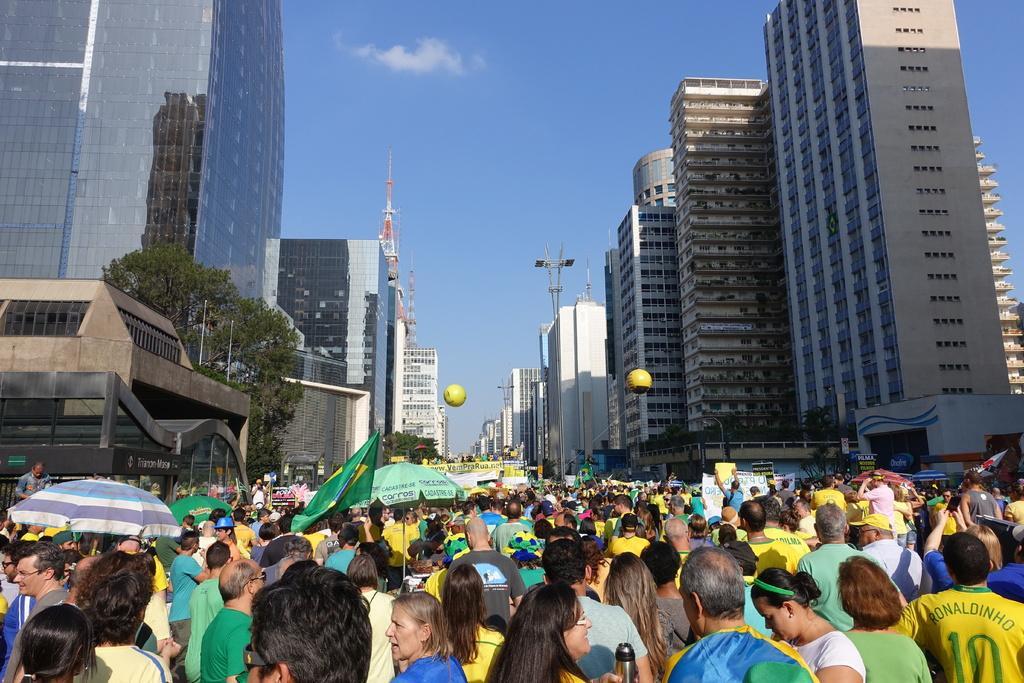Please provide a concise description of this image. In this image I can see number of people are standing. On the left side of this image I can see few umbrellas and a flag. In the background I can see number of buildings, few trees, few yellow colour things in the air and the sky. 